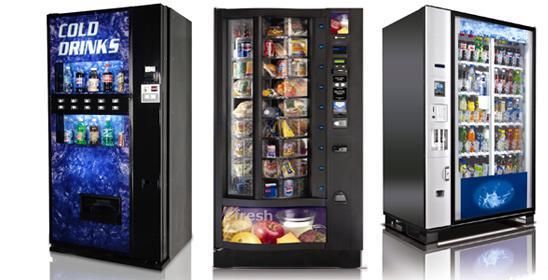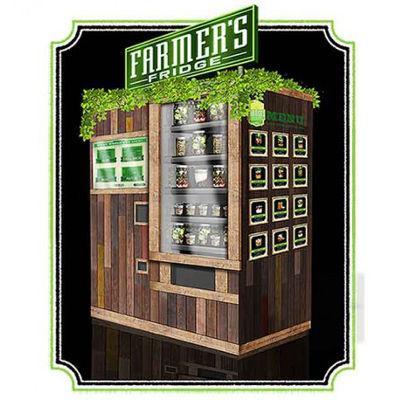The first image is the image on the left, the second image is the image on the right. For the images displayed, is the sentence "Three or more vending machines sell fresh food." factually correct? Answer yes or no. Yes. The first image is the image on the left, the second image is the image on the right. Considering the images on both sides, is "In one of the images, at least three vending machines are lined up together." valid? Answer yes or no. Yes. 